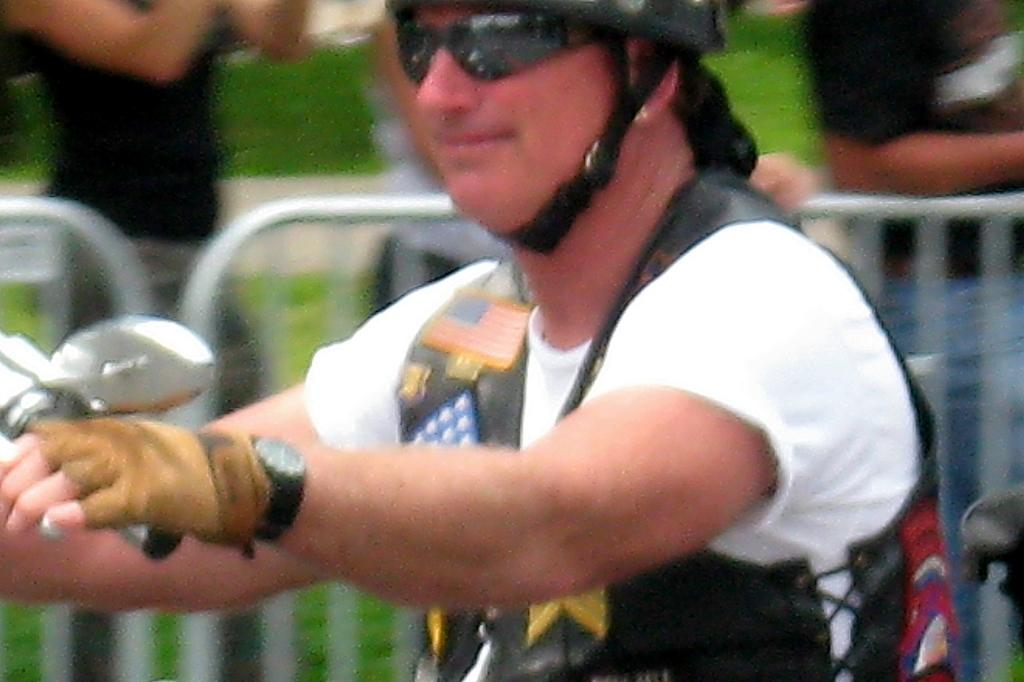What is the person in the image wearing on their head? The person in the image is wearing a helmet. What activity is the person with the helmet engaged in? The person is riding a bike. Are there any other people present in the image? Yes, there are people standing in the image. What feature can be seen in the image that might be used for safety or support? Railings are visible in the image. How does the person make a decision about the snow in the image? There is no snow present in the image, so the person cannot make a decision about it. 